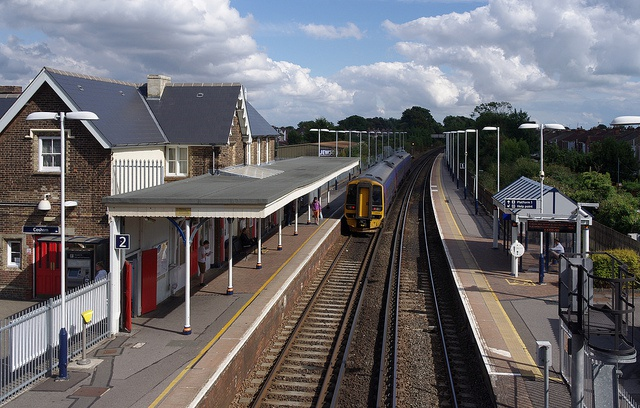Describe the objects in this image and their specific colors. I can see train in gray, black, and maroon tones, people in gray, black, and maroon tones, bench in black and gray tones, people in black, maroon, and gray tones, and people in gray, black, darkgray, and navy tones in this image. 